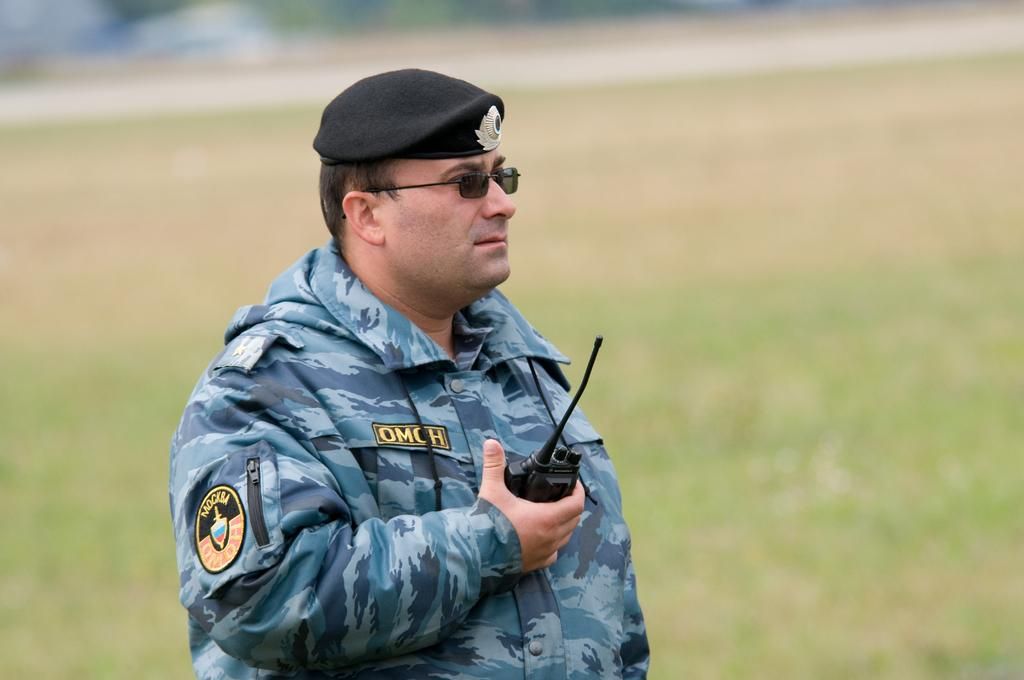What is the main subject of the image? There is a person in the image. What is the person holding in the image? The person is holding a phone. Can you describe the person's appearance? The person is wearing glasses (specs) and a cap. What can be seen on the person's dress? The person has an emblem on their dress. How would you describe the background of the image? The background of the image is blurred. How many giraffes can be seen in the background of the image? There are no giraffes present in the image; the background is blurred. What type of snow can be seen on the person's cap in the image? There is no snow present in the image, and the person is wearing a cap without any snow on it. 